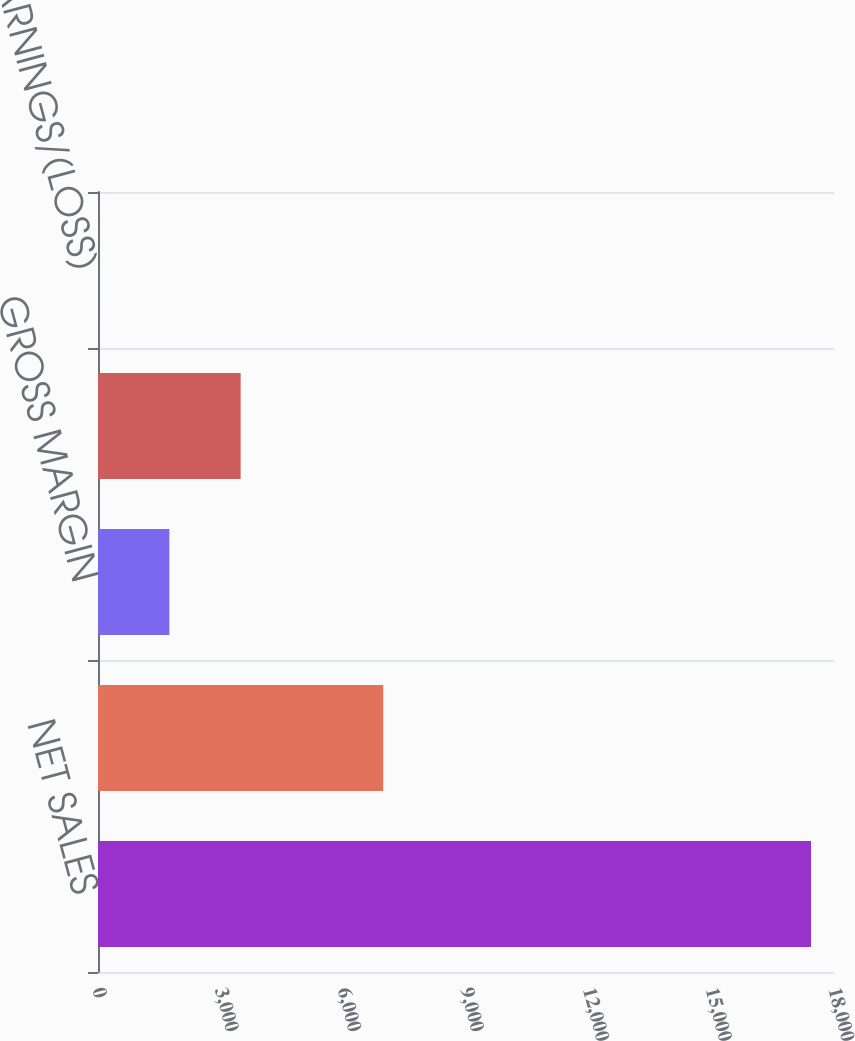Convert chart to OTSL. <chart><loc_0><loc_0><loc_500><loc_500><bar_chart><fcel>NET SALES<fcel>OPERATING INCOME<fcel>GROSS MARGIN<fcel>Net earnings/(loss)<fcel>DILUTED NET EARNINGS/(LOSS)<nl><fcel>17438<fcel>6975.94<fcel>1744.9<fcel>3488.58<fcel>1.22<nl></chart> 